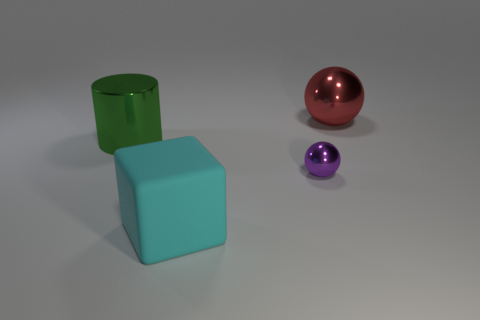Add 4 large red spheres. How many objects exist? 8 Subtract all cylinders. How many objects are left? 3 Add 1 large matte blocks. How many large matte blocks are left? 2 Add 1 big cylinders. How many big cylinders exist? 2 Subtract 0 blue cylinders. How many objects are left? 4 Subtract all big cyan matte cylinders. Subtract all green metal things. How many objects are left? 3 